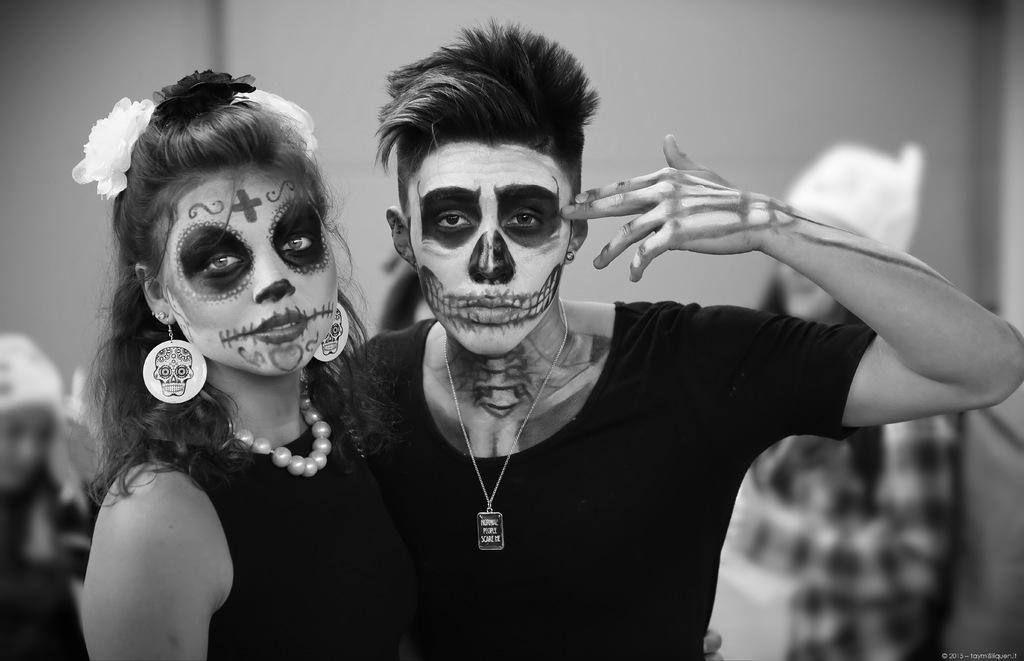How many people are present in the image? There are two persons standing in the image. What is unique about the appearance of these two persons? There is a painting on the faces of the two persons. Can you describe the background of the image? There is a group of people at the back of the image and a wall visible in the image. What type of oven is visible in the image? There is no oven present in the image. Can you tell me how many friends are standing next to the two persons with painted faces? The provided facts do not mention any friends or specify the relationship between the people in the image. 